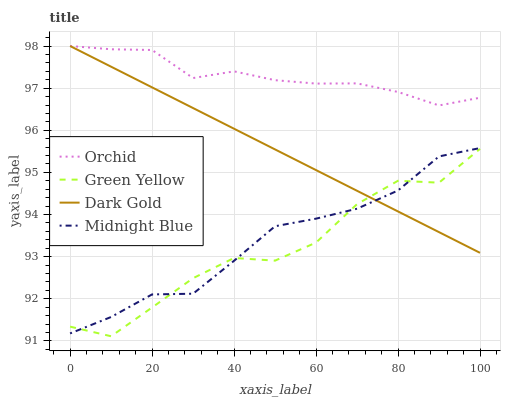Does Green Yellow have the minimum area under the curve?
Answer yes or no. Yes. Does Orchid have the maximum area under the curve?
Answer yes or no. Yes. Does Midnight Blue have the minimum area under the curve?
Answer yes or no. No. Does Midnight Blue have the maximum area under the curve?
Answer yes or no. No. Is Dark Gold the smoothest?
Answer yes or no. Yes. Is Green Yellow the roughest?
Answer yes or no. Yes. Is Midnight Blue the smoothest?
Answer yes or no. No. Is Midnight Blue the roughest?
Answer yes or no. No. Does Green Yellow have the lowest value?
Answer yes or no. Yes. Does Midnight Blue have the lowest value?
Answer yes or no. No. Does Orchid have the highest value?
Answer yes or no. Yes. Does Midnight Blue have the highest value?
Answer yes or no. No. Is Green Yellow less than Orchid?
Answer yes or no. Yes. Is Orchid greater than Midnight Blue?
Answer yes or no. Yes. Does Orchid intersect Dark Gold?
Answer yes or no. Yes. Is Orchid less than Dark Gold?
Answer yes or no. No. Is Orchid greater than Dark Gold?
Answer yes or no. No. Does Green Yellow intersect Orchid?
Answer yes or no. No. 